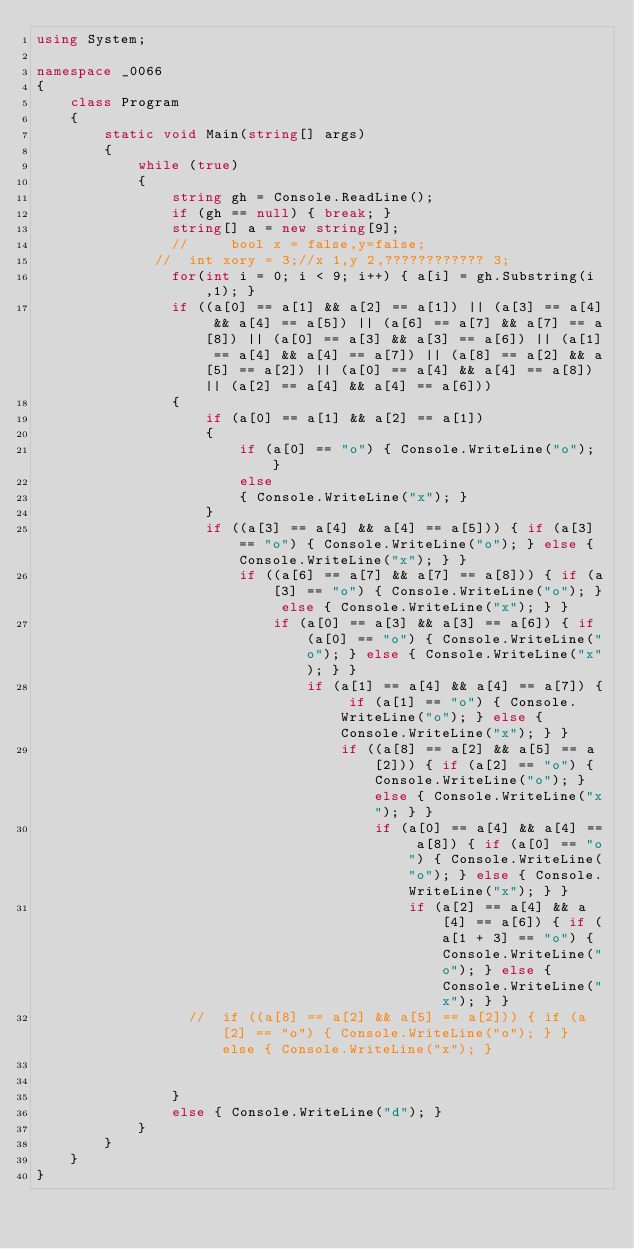Convert code to text. <code><loc_0><loc_0><loc_500><loc_500><_C#_>using System;

namespace _0066
{
    class Program
    {
        static void Main(string[] args)
        {
            while (true)
            {
                string gh = Console.ReadLine();
                if (gh == null) { break; }
                string[] a = new string[9];
                //     bool x = false,y=false;
              //  int xory = 3;//x 1,y 2,???????????? 3;
                for(int i = 0; i < 9; i++) { a[i] = gh.Substring(i,1); }
                if ((a[0] == a[1] && a[2] == a[1]) || (a[3] == a[4] && a[4] == a[5]) || (a[6] == a[7] && a[7] == a[8]) || (a[0] == a[3] && a[3] == a[6]) || (a[1] == a[4] && a[4] == a[7]) || (a[8] == a[2] && a[5] == a[2]) || (a[0] == a[4] && a[4] == a[8]) || (a[2] == a[4] && a[4] == a[6]))
                {
                    if (a[0] == a[1] && a[2] == a[1])
                    {
                        if (a[0] == "o") { Console.WriteLine("o"); }
                        else
                        { Console.WriteLine("x"); }
                    }
                    if ((a[3] == a[4] && a[4] == a[5])) { if (a[3] == "o") { Console.WriteLine("o"); } else { Console.WriteLine("x"); } }
                        if ((a[6] == a[7] && a[7] == a[8])) { if (a[3] == "o") { Console.WriteLine("o"); } else { Console.WriteLine("x"); } }
                            if (a[0] == a[3] && a[3] == a[6]) { if (a[0] == "o") { Console.WriteLine("o"); } else { Console.WriteLine("x"); } }
                                if (a[1] == a[4] && a[4] == a[7]) { if (a[1] == "o") { Console.WriteLine("o"); } else { Console.WriteLine("x"); } }
                                    if ((a[8] == a[2] && a[5] == a[2])) { if (a[2] == "o") { Console.WriteLine("o"); } else { Console.WriteLine("x"); } }
                                        if (a[0] == a[4] && a[4] == a[8]) { if (a[0] == "o") { Console.WriteLine("o"); } else { Console.WriteLine("x"); } }
                                            if (a[2] == a[4] && a[4] == a[6]) { if (a[1 + 3] == "o") { Console.WriteLine("o"); } else { Console.WriteLine("x"); } }
                  //  if ((a[8] == a[2] && a[5] == a[2])) { if (a[2] == "o") { Console.WriteLine("o"); } } else { Console.WriteLine("x"); }


                }
                else { Console.WriteLine("d"); }
            }
        }
    }
}</code> 